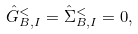Convert formula to latex. <formula><loc_0><loc_0><loc_500><loc_500>\hat { G } ^ { < } _ { B , I } = \hat { \Sigma } ^ { < } _ { B , I } = 0 , \\</formula> 